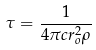<formula> <loc_0><loc_0><loc_500><loc_500>\tau = \frac { 1 } { 4 \pi c r _ { o } ^ { 2 } \rho }</formula> 